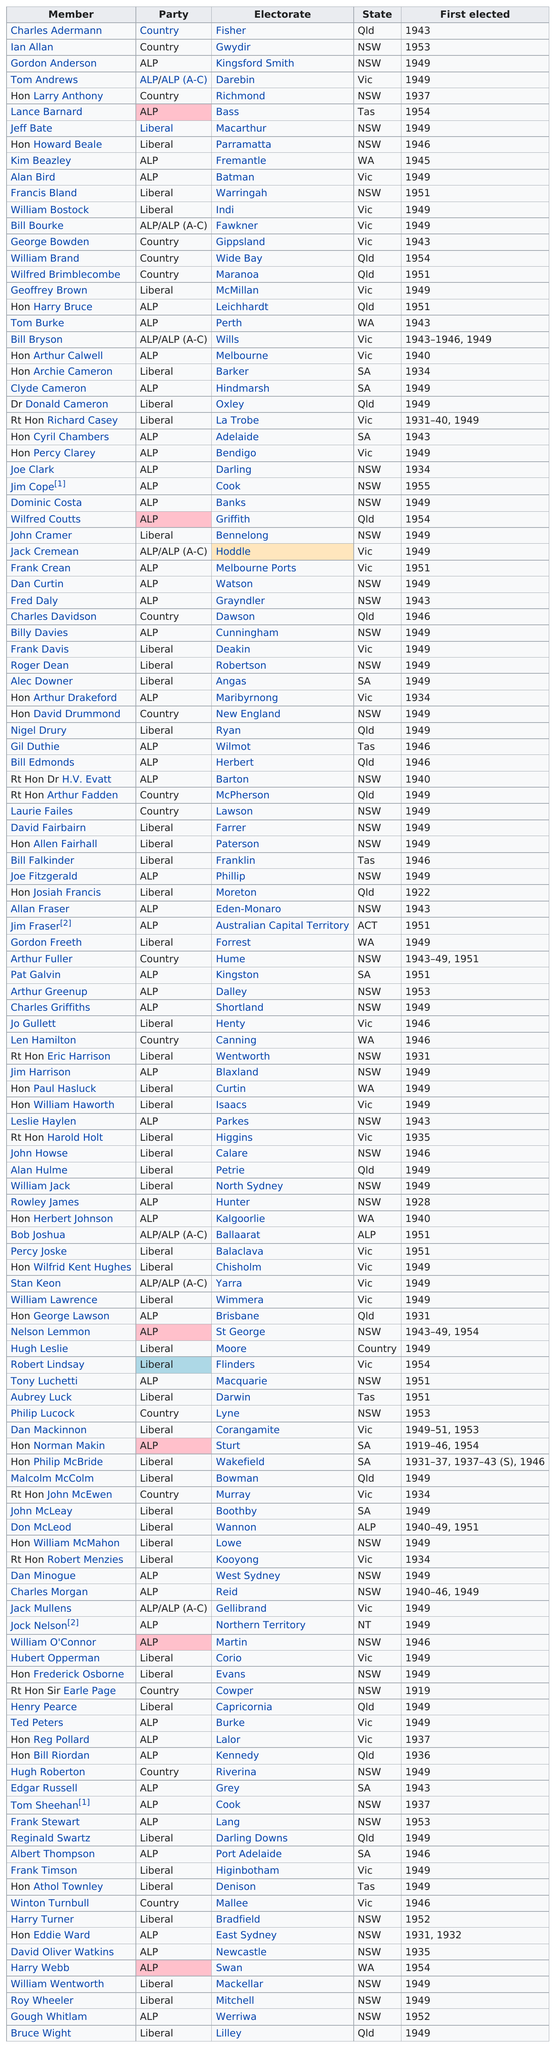Indicate a few pertinent items in this graphic. The party that was elected the least was [party] in [country]. Charles Adermann was the first member to be elected. Tom Andrews was elected, succeeding Gordon Anderson, who previously held the position. According to the results of the recent election, 57 members of the ALPS party have been elected to various positions. After Tom Burke was elected, the next year in which another Tom would be elected was 1937. 